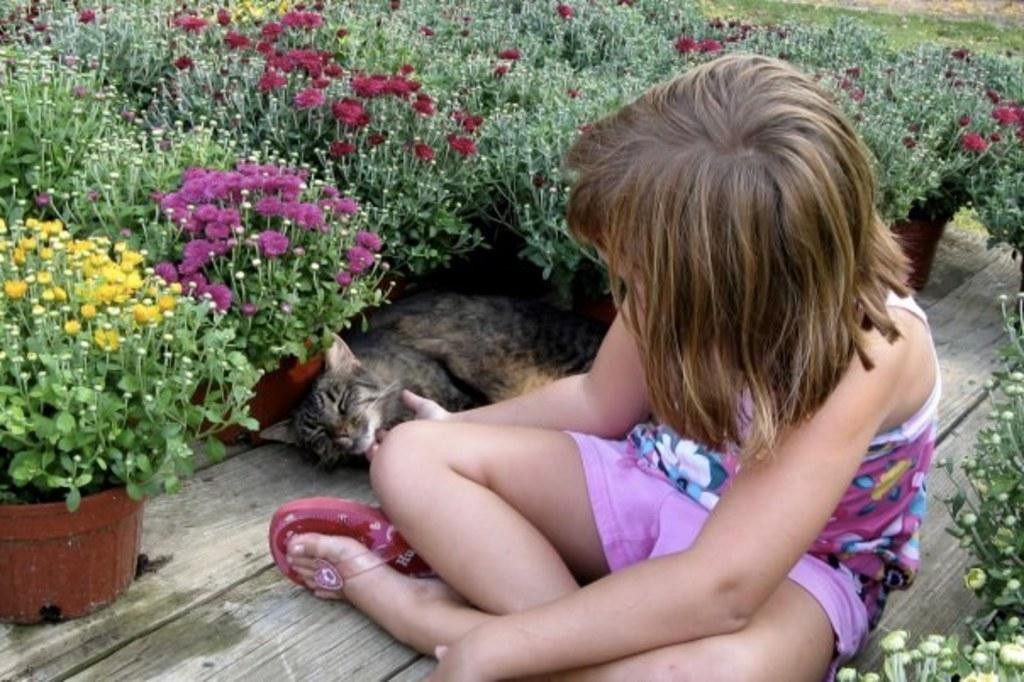Who is the main subject in the image? There is a little girl in the image. What is the girl doing in the image? The girl is sitting. Is there any other living creature in the image? Yes, there is a cat beside the girl. What type of plants can be seen in the image? There are flower plants in the image. What type of cork can be seen in the image? There is no cork present in the image. How many parcels are visible in the image? There are no parcels visible in the image. 